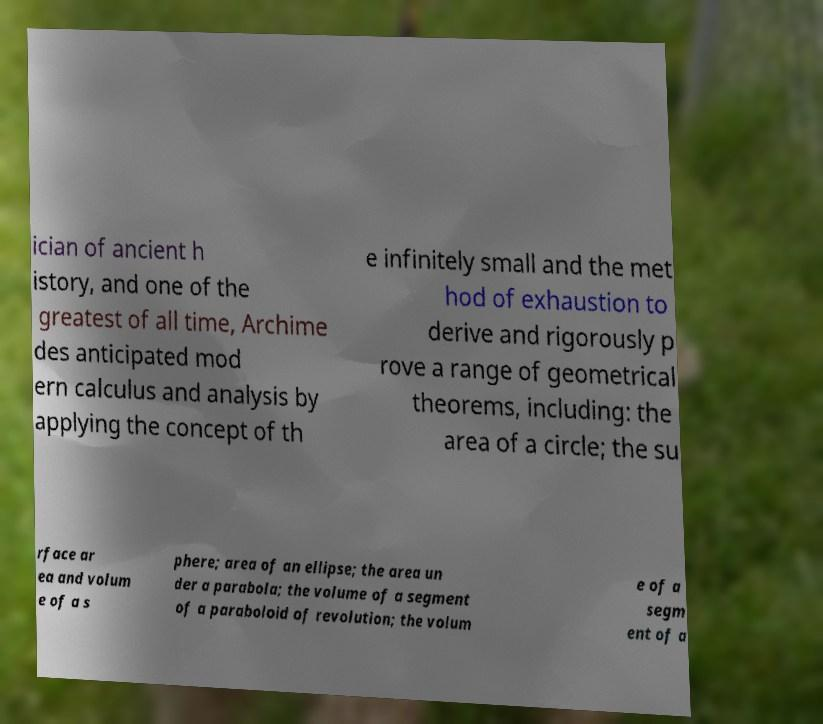Please read and relay the text visible in this image. What does it say? ician of ancient h istory, and one of the greatest of all time, Archime des anticipated mod ern calculus and analysis by applying the concept of th e infinitely small and the met hod of exhaustion to derive and rigorously p rove a range of geometrical theorems, including: the area of a circle; the su rface ar ea and volum e of a s phere; area of an ellipse; the area un der a parabola; the volume of a segment of a paraboloid of revolution; the volum e of a segm ent of a 